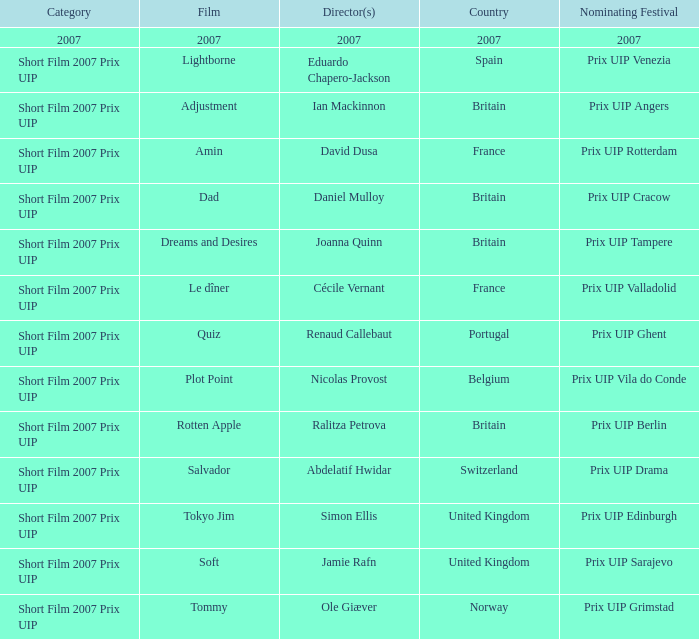What film did abdelatif hwidar direct that was in the short film 2007 prix uip category? Salvador. 